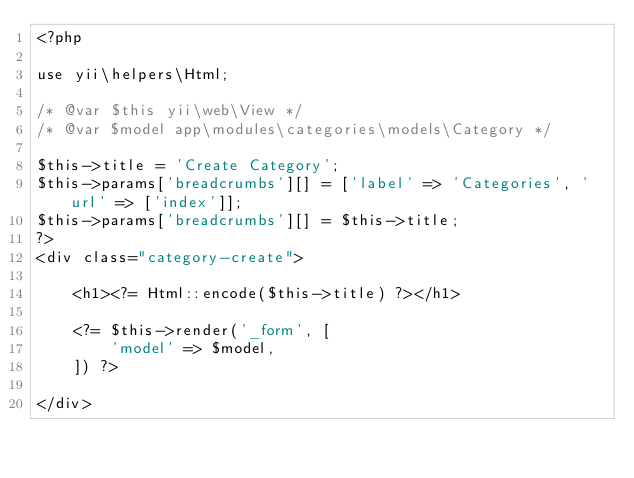Convert code to text. <code><loc_0><loc_0><loc_500><loc_500><_PHP_><?php

use yii\helpers\Html;

/* @var $this yii\web\View */
/* @var $model app\modules\categories\models\Category */

$this->title = 'Create Category';
$this->params['breadcrumbs'][] = ['label' => 'Categories', 'url' => ['index']];
$this->params['breadcrumbs'][] = $this->title;
?>
<div class="category-create">

    <h1><?= Html::encode($this->title) ?></h1>

    <?= $this->render('_form', [
        'model' => $model,
    ]) ?>

</div>
</code> 